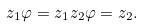<formula> <loc_0><loc_0><loc_500><loc_500>z _ { 1 } \varphi = z _ { 1 } z _ { 2 } \varphi = z _ { 2 } .</formula> 